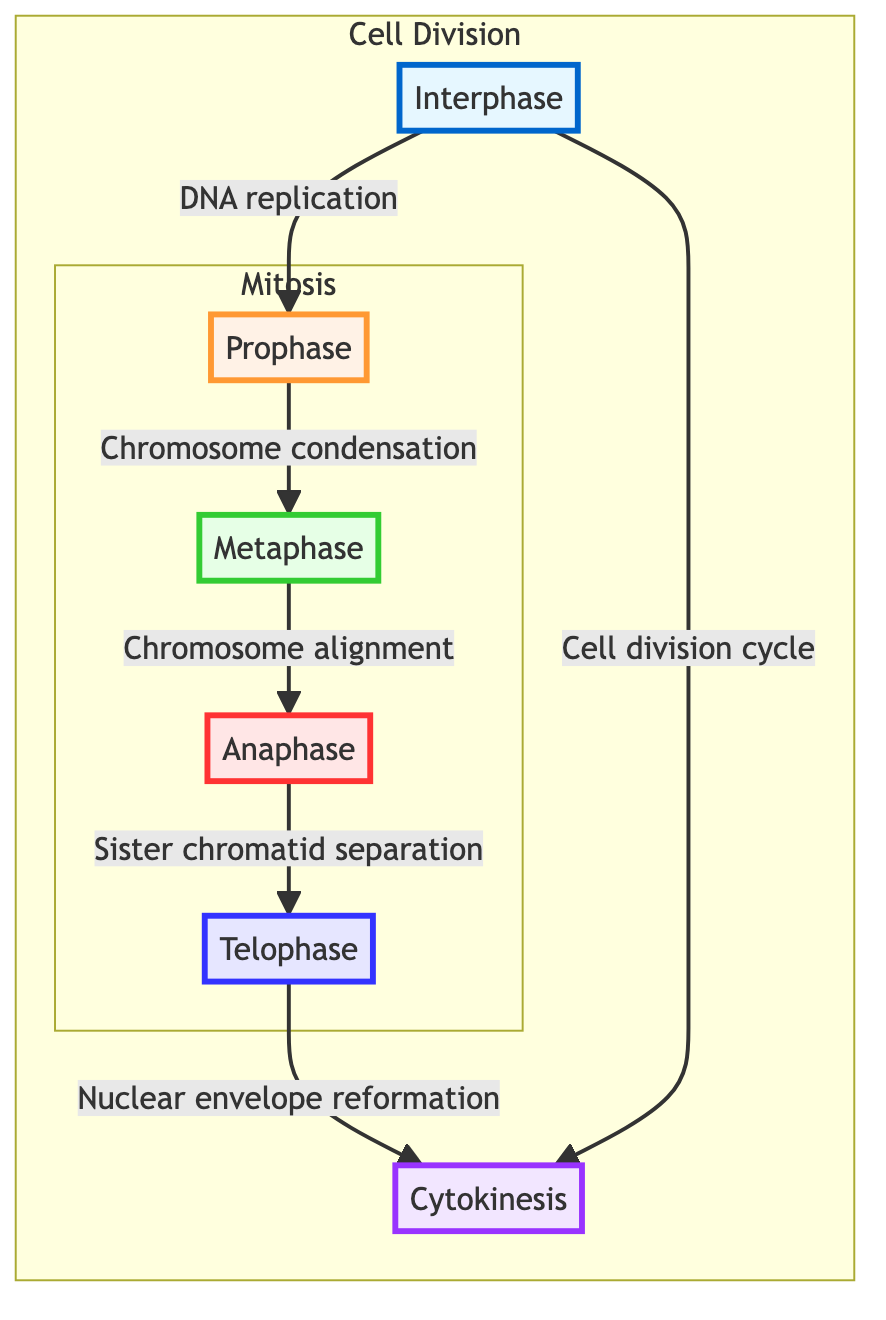What is the first stage of mitosis shown in the diagram? The diagram starts with the first node labeled "Prophase," which is the first stage indicated in the flow of the mitosis stages, following Interphase.
Answer: Prophase How many main stages of mitosis are represented in the diagram? Counting the nodes within the "Mitosis" subgraph, there are four stages: Prophase, Metaphase, Anaphase, and Telophase.
Answer: Four What follows after Anaphase in the flowchart? Following the arrow from Anaphase, the next node is Telophase, indicating the subsequent stage in the mitosis process.
Answer: Telophase What does Interphase prepare for according to the diagram? The description attached to the Interphase node specifies that it prepares for division through DNA and organelle replication.
Answer: Division Which stage involves the alignment of chromosomes at the metaphase plate? The node labeled "Metaphase" directly states that this is when chromosomes align at the metaphase plate, making this the corresponding stage for alignment.
Answer: Metaphase How many phases are part of cell division in the diagram? The "Cell Division" subgraph encapsulates three phases: Interphase, Mitosis (which includes Prophase, Metaphase, Anaphase, and Telophase), and Cytokinesis, summing up to five.
Answer: Five What is the final process completed after Telophase? The diagram indicates that Cytokinesis follows Telophase, leading to the final step of cell division.
Answer: Cytokinesis What color represents the Anaphase stage in the diagram? The styling for the Anaphase node specifies a fill color of light red with a specific stroke color; this represents the phase visually in the flowchart.
Answer: Light red 